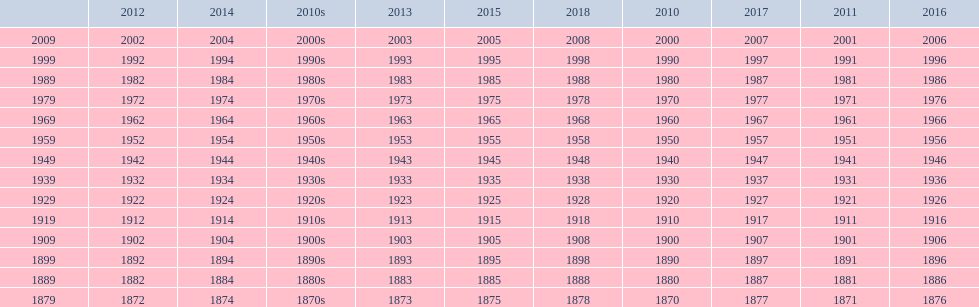Help me parse the entirety of this table. {'header': ['', '2012', '2014', '2010s', '2013', '2015', '2018', '2010', '2017', '2011', '2016'], 'rows': [['2009', '2002', '2004', '2000s', '2003', '2005', '2008', '2000', '2007', '2001', '2006'], ['1999', '1992', '1994', '1990s', '1993', '1995', '1998', '1990', '1997', '1991', '1996'], ['1989', '1982', '1984', '1980s', '1983', '1985', '1988', '1980', '1987', '1981', '1986'], ['1979', '1972', '1974', '1970s', '1973', '1975', '1978', '1970', '1977', '1971', '1976'], ['1969', '1962', '1964', '1960s', '1963', '1965', '1968', '1960', '1967', '1961', '1966'], ['1959', '1952', '1954', '1950s', '1953', '1955', '1958', '1950', '1957', '1951', '1956'], ['1949', '1942', '1944', '1940s', '1943', '1945', '1948', '1940', '1947', '1941', '1946'], ['1939', '1932', '1934', '1930s', '1933', '1935', '1938', '1930', '1937', '1931', '1936'], ['1929', '1922', '1924', '1920s', '1923', '1925', '1928', '1920', '1927', '1921', '1926'], ['1919', '1912', '1914', '1910s', '1913', '1915', '1918', '1910', '1917', '1911', '1916'], ['1909', '1902', '1904', '1900s', '1903', '1905', '1908', '1900', '1907', '1901', '1906'], ['1899', '1892', '1894', '1890s', '1893', '1895', '1898', '1890', '1897', '1891', '1896'], ['1889', '1882', '1884', '1880s', '1883', '1885', '1888', '1880', '1887', '1881', '1886'], ['1879', '1872', '1874', '1870s', '1873', '1875', '1878', '1870', '1877', '1871', '1876']]} True/false: all years go in consecutive order? True. 